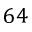Convert formula to latex. <formula><loc_0><loc_0><loc_500><loc_500>6 4</formula> 